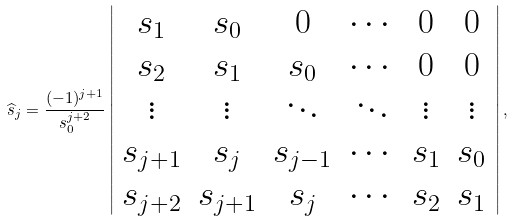<formula> <loc_0><loc_0><loc_500><loc_500>\widehat { s } _ { j } = \frac { ( - 1 ) ^ { j + 1 } } { s _ { 0 } ^ { j + 2 } } \left | \begin{array} { c c c c c c } s _ { 1 } & s _ { 0 } & 0 & \cdots & 0 & 0 \\ s _ { 2 } & s _ { 1 } & s _ { 0 } & \cdots & 0 & 0 \\ \vdots & \vdots & \ddots & \ddots & \vdots & \vdots \\ s _ { j + 1 } & s _ { j } & s _ { j - 1 } & \cdots & s _ { 1 } & s _ { 0 } \\ s _ { j + 2 } & s _ { j + 1 } & s _ { j } & \cdots & s _ { 2 } & s _ { 1 } \end{array} \right | ,</formula> 